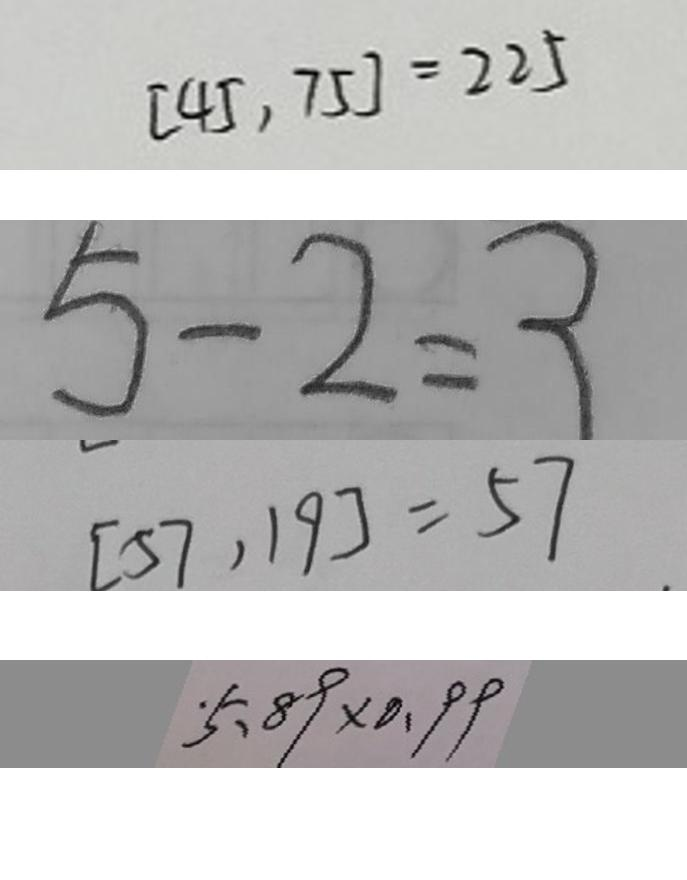Convert formula to latex. <formula><loc_0><loc_0><loc_500><loc_500>[ 4 5 , 7 5 ] = 2 2 5 
 5 - 2 = 3 
 [ 5 7 , 1 9 ] = 5 7 
 5 . 8 9 \times 0 . 9 9</formula> 